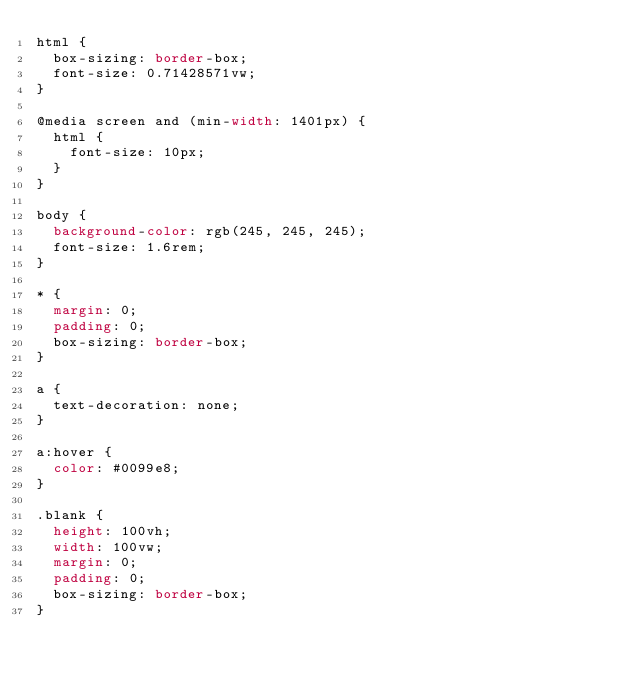<code> <loc_0><loc_0><loc_500><loc_500><_CSS_>html {
  box-sizing: border-box;
  font-size: 0.71428571vw;
}

@media screen and (min-width: 1401px) {
  html {
    font-size: 10px;
  }
}

body {
  background-color: rgb(245, 245, 245);
  font-size: 1.6rem;
}

* {
  margin: 0;
  padding: 0;
  box-sizing: border-box;
}

a {
  text-decoration: none;
}

a:hover {
  color: #0099e8;
}

.blank {
  height: 100vh;
  width: 100vw;
  margin: 0;
  padding: 0;
  box-sizing: border-box;
}</code> 